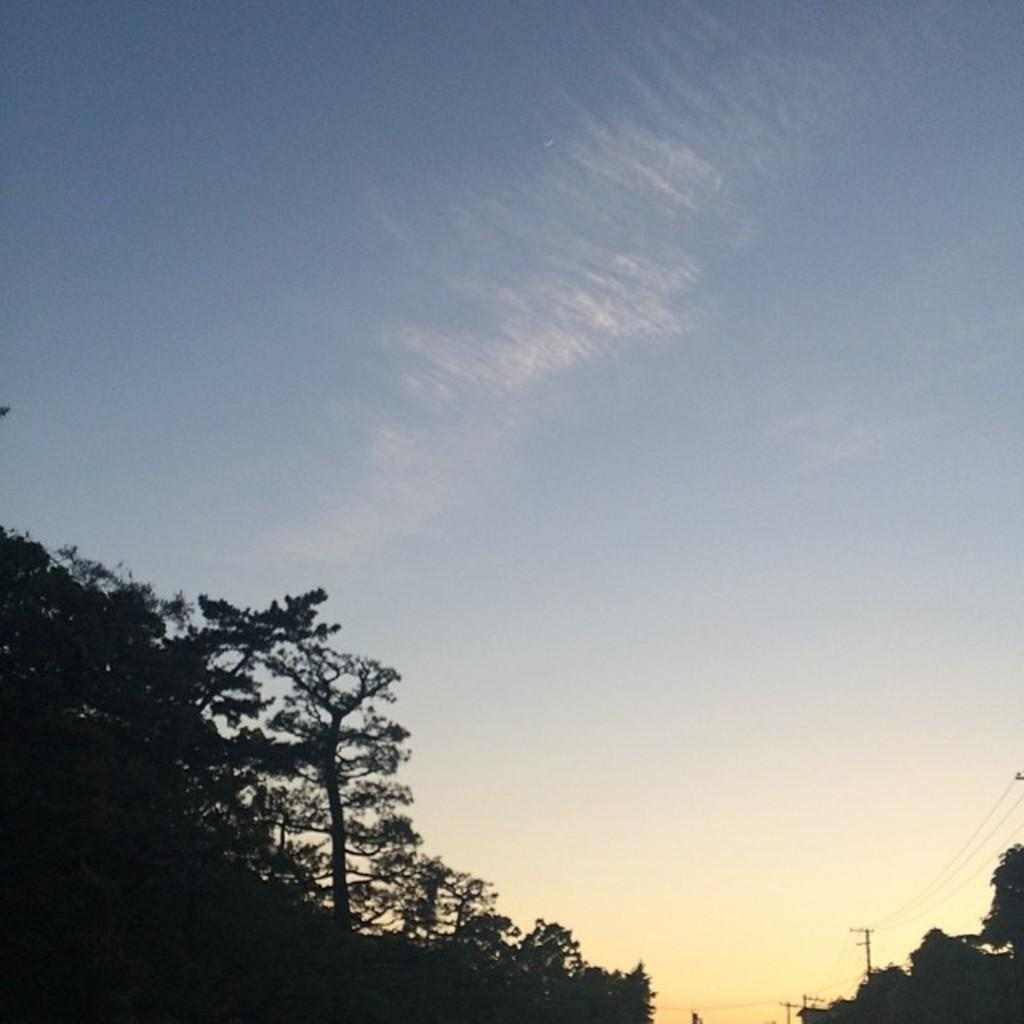What type of natural elements can be seen in the image? There are trees in the image. What man-made structures are present in the image? There are poles and wires in the image. What is the color of the sky in the image? The sky is blue and white in color. Can you tell me how many bulbs are hanging from the trees in the image? There are no bulbs present in the image; it features trees, poles, and wires. What type of trail can be seen in the image? There is no trail visible in the image; it primarily consists of trees, poles, wires, and a blue and white sky. 